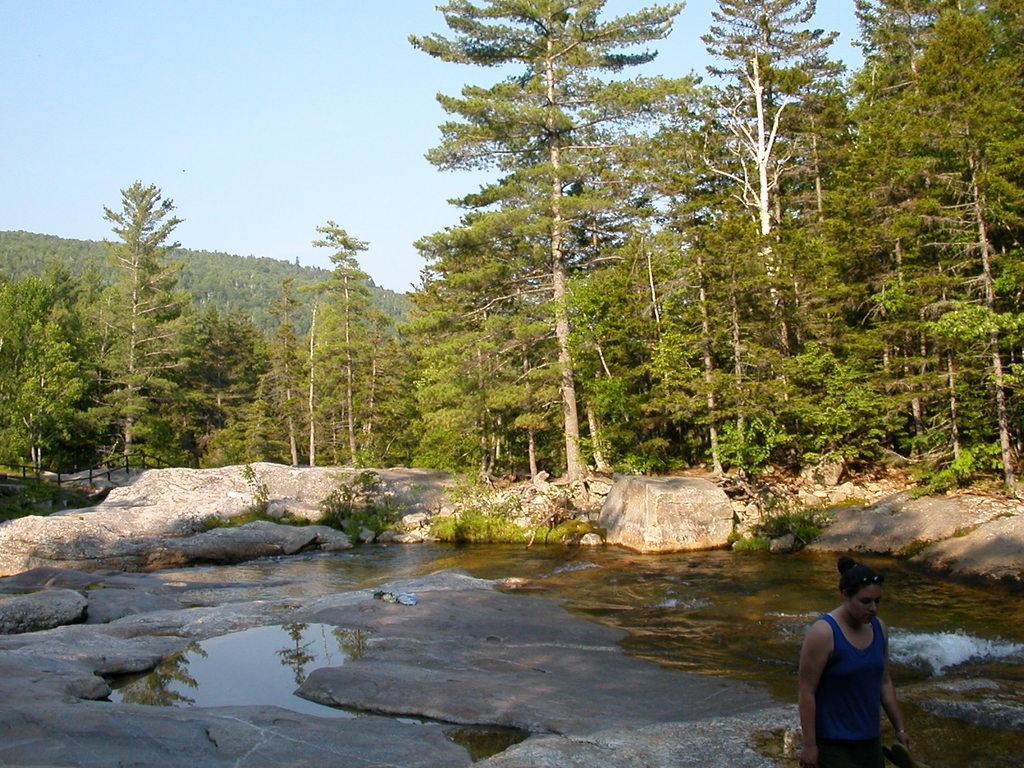Can you describe this image briefly? In the image we can see there is water on the ground and there are rocks. Behind there are lot of trees and there is a woman standing. There is a clear sky. 